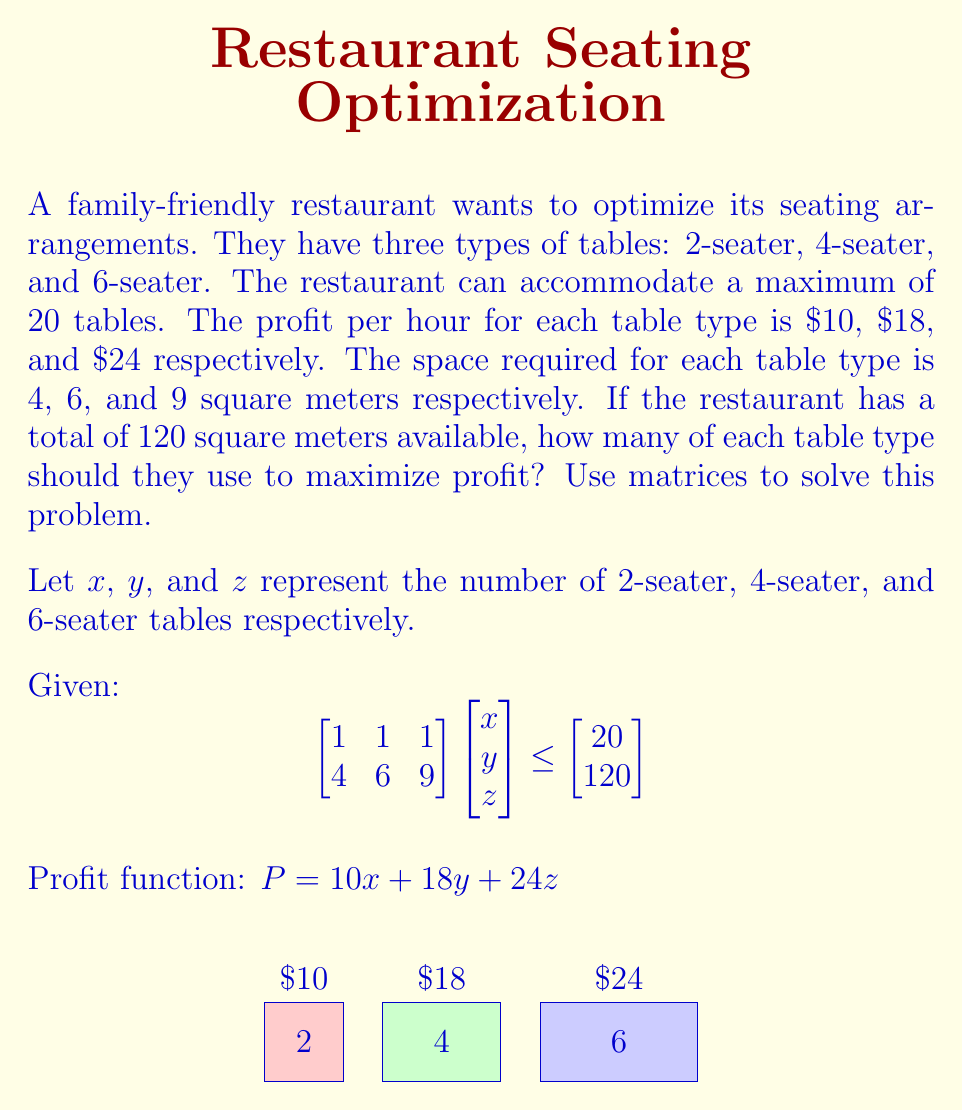Teach me how to tackle this problem. To solve this problem using matrices, we'll follow these steps:

1) First, we need to set up the constraints using the given matrix inequality:
   $$\begin{bmatrix}
   1 & 1 & 1 \\
   4 & 6 & 9
   \end{bmatrix}
   \begin{bmatrix}
   x \\ y \\ z
   \end{bmatrix}
   \leq
   \begin{bmatrix}
   20 \\ 120
   \end{bmatrix}$$

   This gives us two constraints:
   $x + y + z \leq 20$ (total tables)
   $4x + 6y + 9z \leq 120$ (total space)

2) We also know that $x$, $y$, and $z$ must be non-negative integers.

3) Our objective is to maximize the profit function:
   $P = 10x + 18y + 24z$

4) This is an integer linear programming problem. We can solve it using the simplex method and then round down to the nearest integer solution.

5) Using a linear programming solver, we get the optimal solution:
   $x \approx 0$
   $y \approx 13.33$
   $z \approx 6.67$

6) Rounding down to respect the integer constraint:
   $x = 0$
   $y = 13$
   $z = 6$

7) We can verify that this solution satisfies our constraints:
   $0 + 13 + 6 = 19 \leq 20$
   $4(0) + 6(13) + 9(6) = 78 + 54 = 132 \leq 120$

8) The maximum profit is therefore:
   $P = 10(0) + 18(13) + 24(6) = 234 + 144 = 378$
Answer: 0 2-seater, 13 4-seater, 6 6-seater tables; $378 profit per hour 